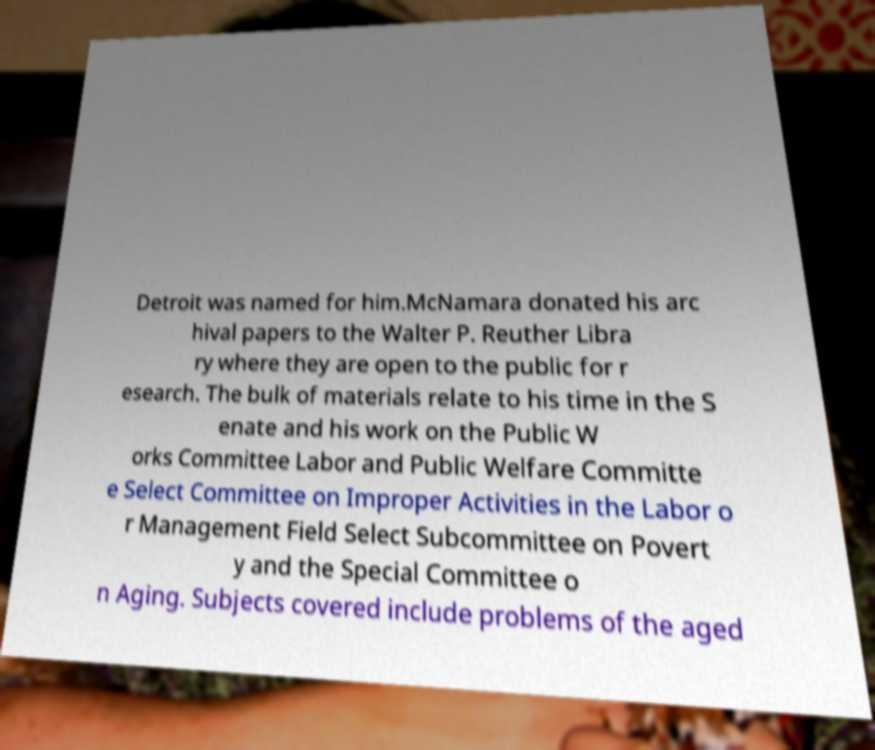What messages or text are displayed in this image? I need them in a readable, typed format. Detroit was named for him.McNamara donated his arc hival papers to the Walter P. Reuther Libra ry where they are open to the public for r esearch. The bulk of materials relate to his time in the S enate and his work on the Public W orks Committee Labor and Public Welfare Committe e Select Committee on Improper Activities in the Labor o r Management Field Select Subcommittee on Povert y and the Special Committee o n Aging. Subjects covered include problems of the aged 